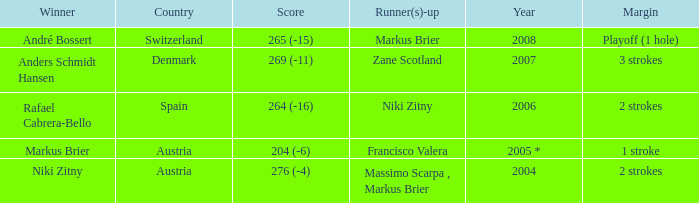In what year was the score 204 (-6)? 2005 *. 